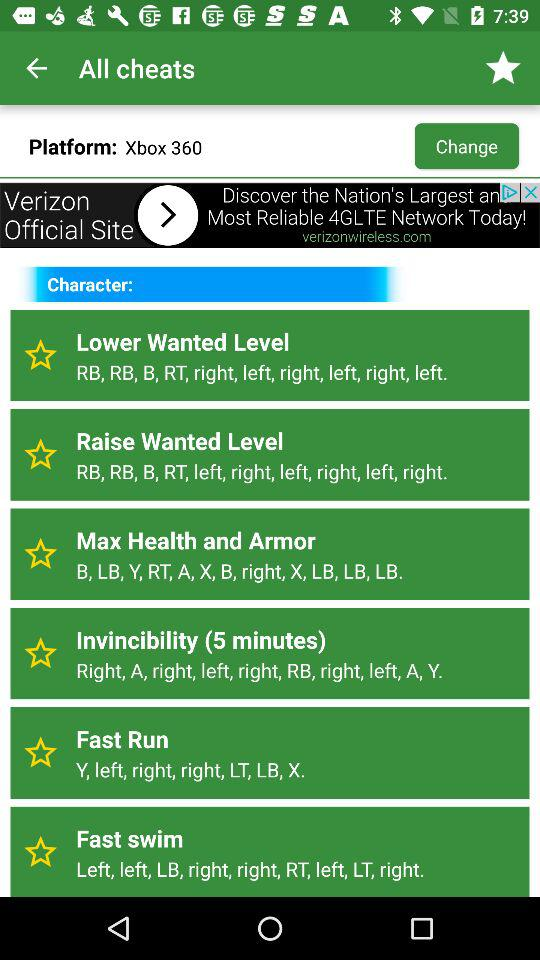What are the different cheat options available for "Xbox 360"? The different cheat options are "Lower Wanted Level", "Raise Wanted Level", "Max Health and Armor", "Invincibility (5 minutes)", "Fast Run" and "Fast swim". 